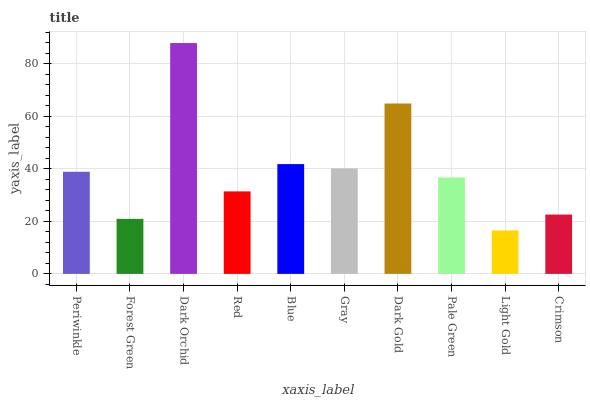Is Forest Green the minimum?
Answer yes or no. No. Is Forest Green the maximum?
Answer yes or no. No. Is Periwinkle greater than Forest Green?
Answer yes or no. Yes. Is Forest Green less than Periwinkle?
Answer yes or no. Yes. Is Forest Green greater than Periwinkle?
Answer yes or no. No. Is Periwinkle less than Forest Green?
Answer yes or no. No. Is Periwinkle the high median?
Answer yes or no. Yes. Is Pale Green the low median?
Answer yes or no. Yes. Is Light Gold the high median?
Answer yes or no. No. Is Crimson the low median?
Answer yes or no. No. 